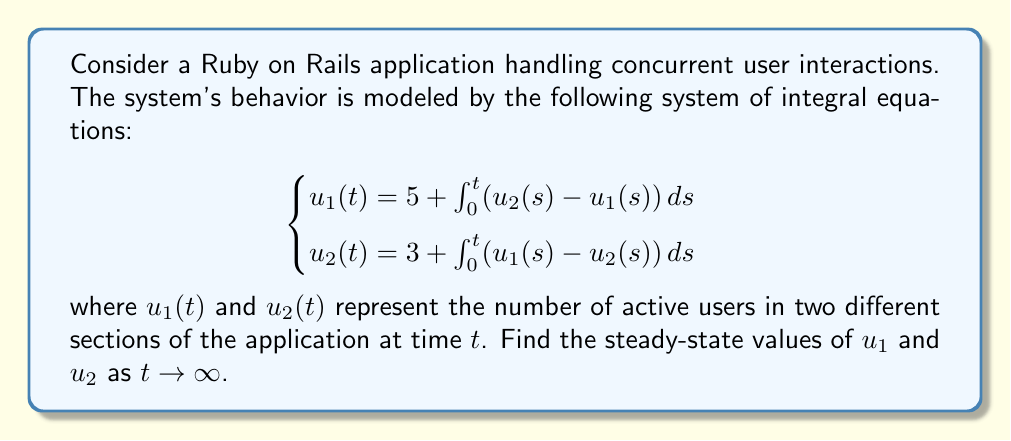Can you solve this math problem? To solve this problem, we'll follow these steps:

1) In the steady-state, the derivatives of $u_1$ and $u_2$ with respect to $t$ will be zero. So, we can differentiate both equations:

   $$\begin{cases}
   \frac{du_1}{dt} = u_2(t) - u_1(t) \\
   \frac{du_2}{dt} = u_1(t) - u_2(t)
   \end{cases}$$

2) At steady-state, set these derivatives to zero:

   $$\begin{cases}
   0 = u_2 - u_1 \\
   0 = u_1 - u_2
   \end{cases}$$

3) From these equations, we can conclude that at steady-state, $u_1 = u_2$. Let's call this common value $u$.

4) Now, let's go back to the original integral equations. At steady-state, the integrals will be constant, so we can write:

   $$\begin{cases}
   u = 5 + k(u - u) \\
   u = 3 + k(u - u)
   \end{cases}$$

   where $k$ is some constant.

5) Simplifying:

   $$\begin{cases}
   u = 5 \\
   u = 3
   \end{cases}$$

6) These equations are inconsistent unless $u = 4$, which is the average of 5 and 3.

Therefore, the steady-state values are $u_1 = u_2 = 4$.
Answer: $u_1 = u_2 = 4$ 